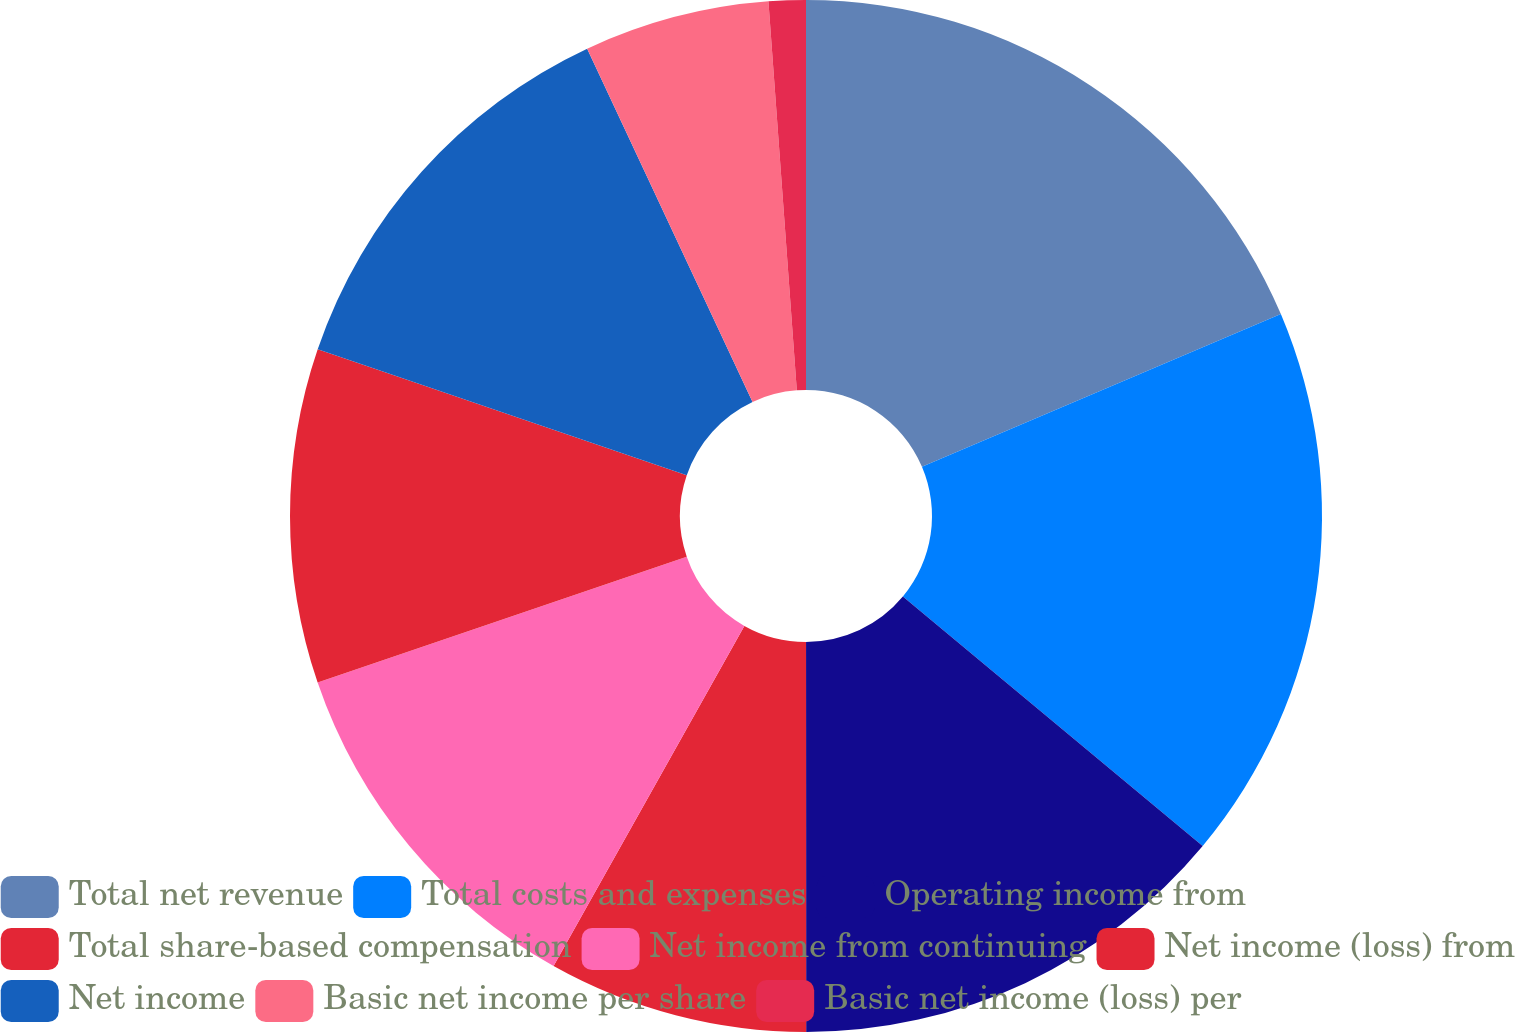Convert chart. <chart><loc_0><loc_0><loc_500><loc_500><pie_chart><fcel>Total net revenue<fcel>Total costs and expenses<fcel>Operating income from<fcel>Total share-based compensation<fcel>Net income from continuing<fcel>Net income (loss) from<fcel>Net income<fcel>Basic net income per share<fcel>Basic net income (loss) per<nl><fcel>18.6%<fcel>17.44%<fcel>13.95%<fcel>8.14%<fcel>11.63%<fcel>10.47%<fcel>12.79%<fcel>5.81%<fcel>1.16%<nl></chart> 